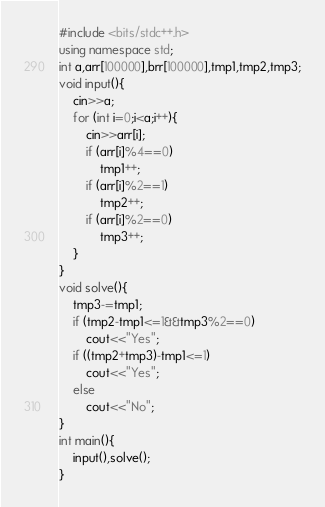Convert code to text. <code><loc_0><loc_0><loc_500><loc_500><_C++_>#include <bits/stdc++.h>
using namespace std;
int a,arr[100000],brr[100000],tmp1,tmp2,tmp3;
void input(){
    cin>>a;
    for (int i=0;i<a;i++){
        cin>>arr[i];
        if (arr[i]%4==0)
            tmp1++;
        if (arr[i]%2==1)
            tmp2++;
        if (arr[i]%2==0)
            tmp3++;
    }
}
void solve(){
    tmp3-=tmp1;
    if (tmp2-tmp1<=1&&tmp3%2==0)
        cout<<"Yes";
    if ((tmp2+tmp3)-tmp1<=1)
        cout<<"Yes";
    else
        cout<<"No";
}
int main(){
    input(),solve();
}
</code> 